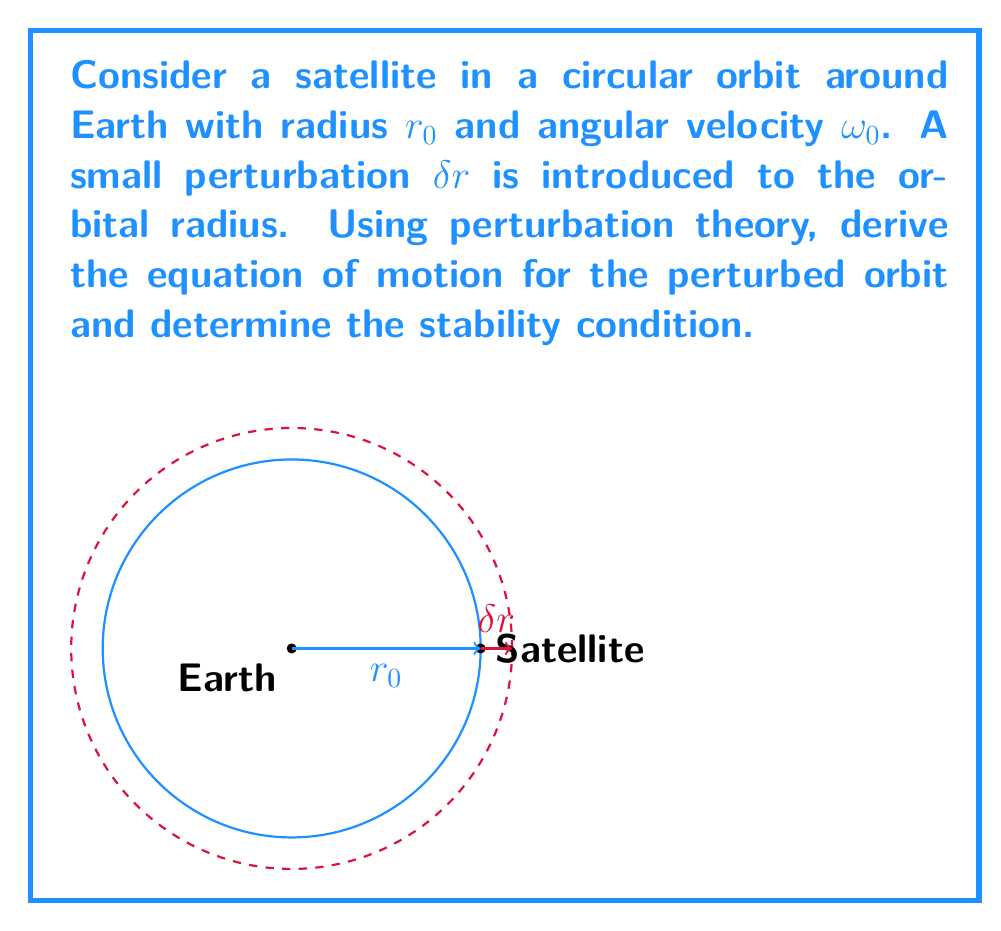Give your solution to this math problem. Let's approach this step-by-step:

1) The gravitational force on the satellite is given by:

   $$F = -\frac{GMm}{r^2}$$

   where $G$ is the gravitational constant, $M$ is Earth's mass, and $m$ is the satellite's mass.

2) For a circular orbit, this force provides the centripetal acceleration:

   $$\frac{GMm}{r_0^2} = m\omega_0^2r_0$$

3) Now, let's consider a small perturbation $\delta r$. The new radius is $r = r_0 + \delta r$.

4) The equation of motion for the perturbed orbit is:

   $$m\ddot{r} = -\frac{GMm}{r^2} + mr\omega^2$$

5) Expand $\frac{1}{r^2}$ using the binomial theorem and keep only first-order terms:

   $$\frac{1}{r^2} \approx \frac{1}{r_0^2}(1 - 2\frac{\delta r}{r_0})$$

6) Substitute this into the equation of motion:

   $$\ddot{\delta r} = -\frac{GM}{r_0^2}(1 - 2\frac{\delta r}{r_0}) + (r_0 + \delta r)\omega^2$$

7) Use the relation $\omega_0^2 = \frac{GM}{r_0^3}$ and assume $\omega \approx \omega_0$ for small perturbations:

   $$\ddot{\delta r} = -\omega_0^2r_0(1 - 2\frac{\delta r}{r_0}) + (r_0 + \delta r)\omega_0^2$$

8) Simplify and keep only first-order terms in $\delta r$:

   $$\ddot{\delta r} = 3\omega_0^2\delta r$$

9) This is a simple harmonic oscillator equation with frequency $\sqrt{3}\omega_0$.

10) For stability, the solution should be oscillatory, which it is in this case.
Answer: $\ddot{\delta r} = 3\omega_0^2\delta r$; stable 